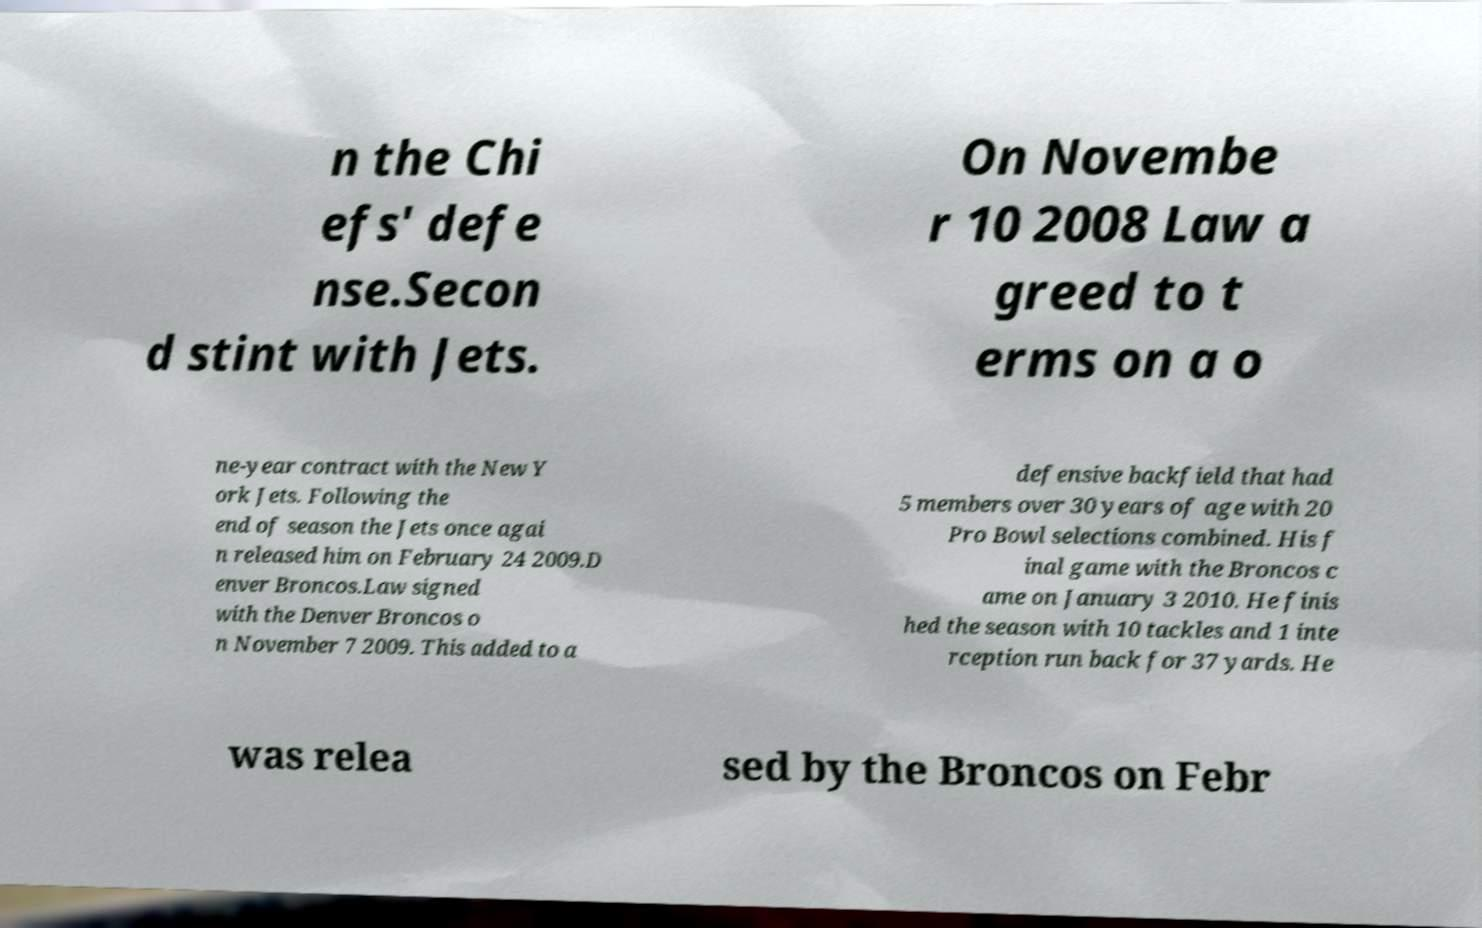Could you extract and type out the text from this image? n the Chi efs' defe nse.Secon d stint with Jets. On Novembe r 10 2008 Law a greed to t erms on a o ne-year contract with the New Y ork Jets. Following the end of season the Jets once agai n released him on February 24 2009.D enver Broncos.Law signed with the Denver Broncos o n November 7 2009. This added to a defensive backfield that had 5 members over 30 years of age with 20 Pro Bowl selections combined. His f inal game with the Broncos c ame on January 3 2010. He finis hed the season with 10 tackles and 1 inte rception run back for 37 yards. He was relea sed by the Broncos on Febr 